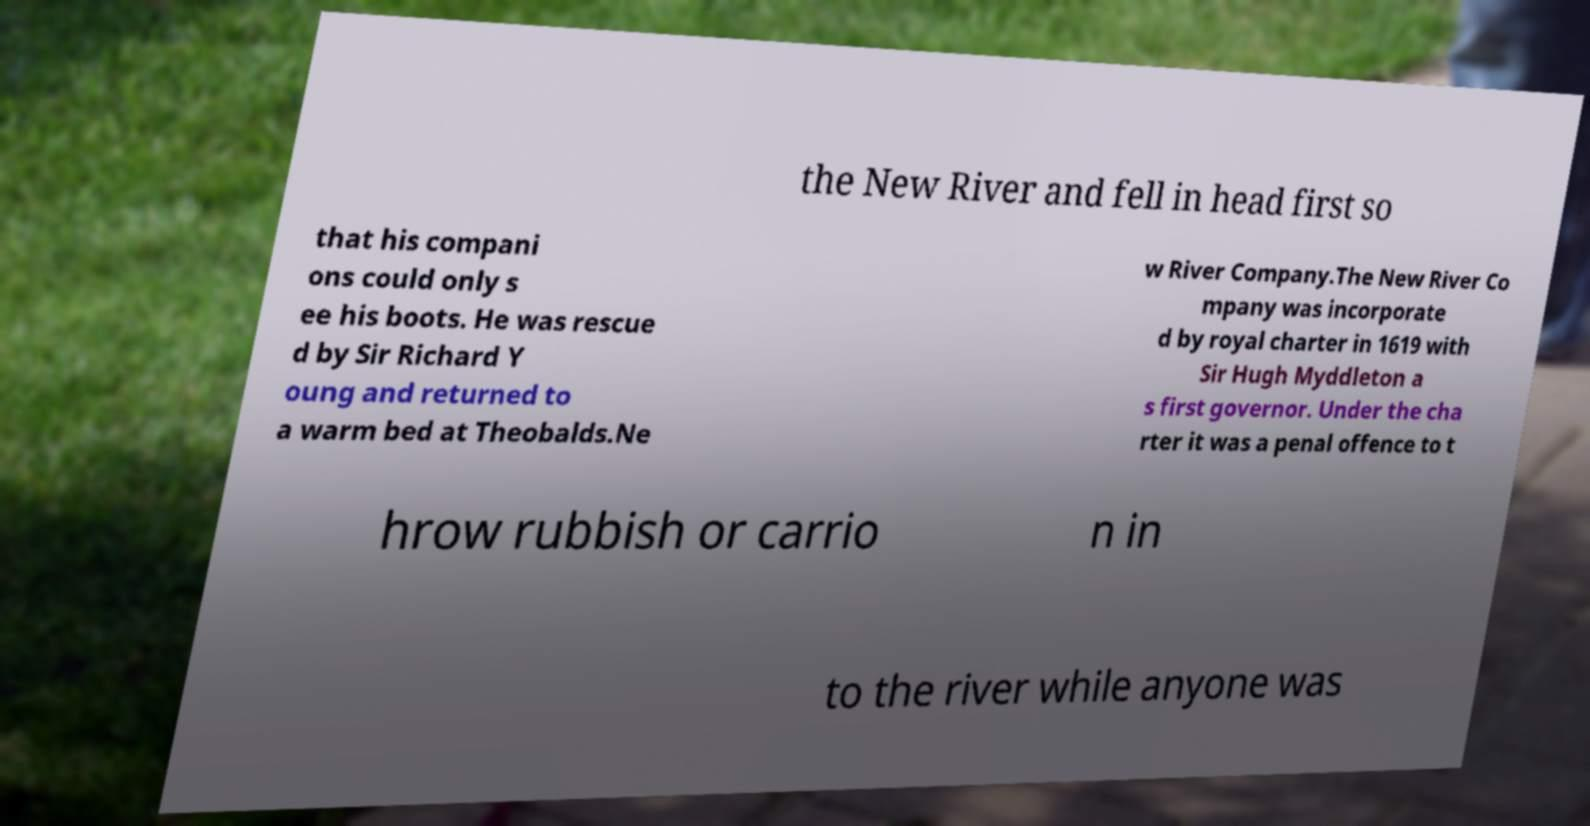For documentation purposes, I need the text within this image transcribed. Could you provide that? the New River and fell in head first so that his compani ons could only s ee his boots. He was rescue d by Sir Richard Y oung and returned to a warm bed at Theobalds.Ne w River Company.The New River Co mpany was incorporate d by royal charter in 1619 with Sir Hugh Myddleton a s first governor. Under the cha rter it was a penal offence to t hrow rubbish or carrio n in to the river while anyone was 